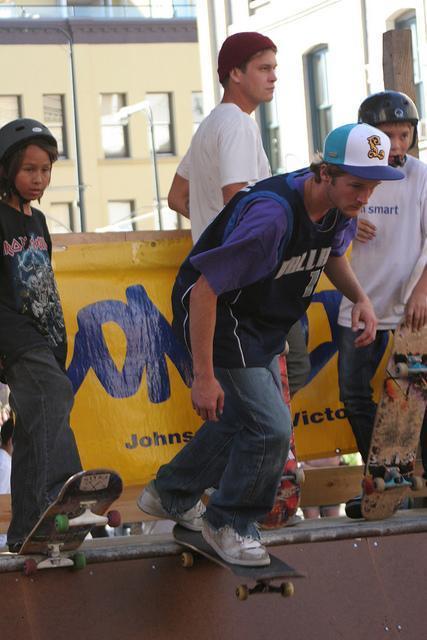How many people are wearing helmets?
Give a very brief answer. 2. How many kids are wearing helmets?
Give a very brief answer. 2. How many skateboards are in the photo?
Give a very brief answer. 3. How many people can you see?
Give a very brief answer. 4. How many tiers does this cake have?
Give a very brief answer. 0. 